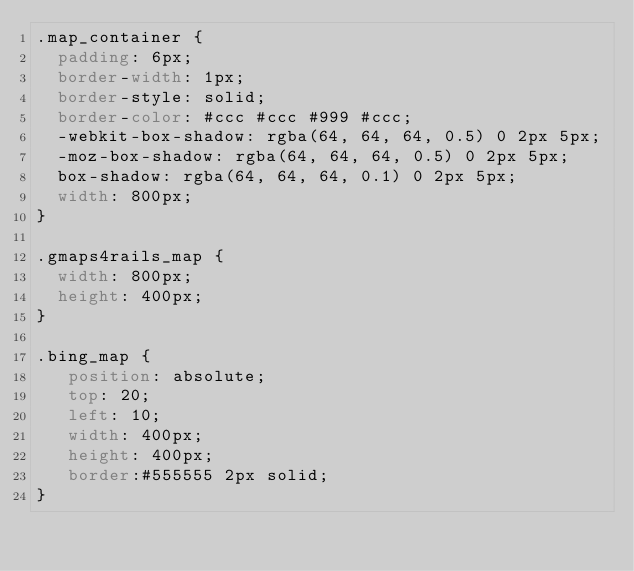<code> <loc_0><loc_0><loc_500><loc_500><_CSS_>.map_container {
  padding: 6px;
  border-width: 1px;
  border-style: solid;
  border-color: #ccc #ccc #999 #ccc;
  -webkit-box-shadow: rgba(64, 64, 64, 0.5) 0 2px 5px;
  -moz-box-shadow: rgba(64, 64, 64, 0.5) 0 2px 5px;
  box-shadow: rgba(64, 64, 64, 0.1) 0 2px 5px;
  width: 800px;
}

.gmaps4rails_map {
  width: 800px;
  height: 400px;
}

.bing_map {
   position: absolute;
   top: 20;
   left: 10;
   width: 400px;
   height: 400px;
   border:#555555 2px solid;
}
</code> 